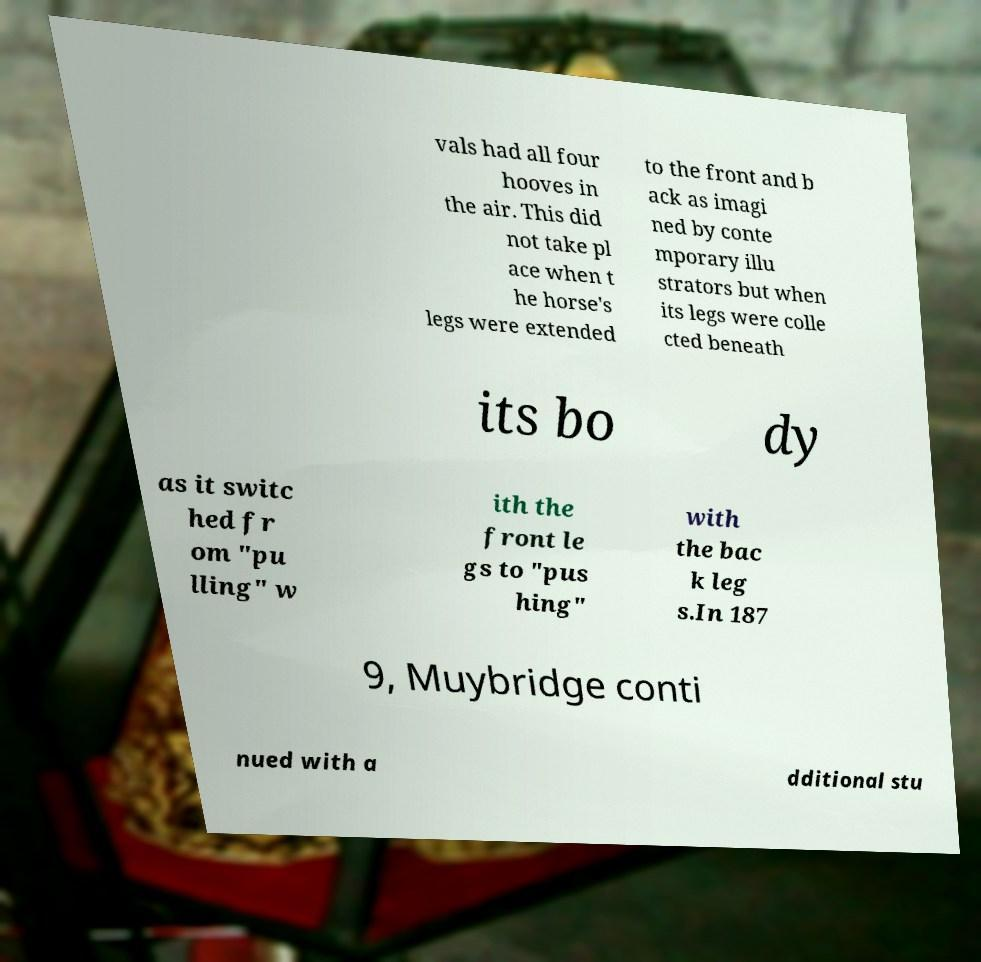For documentation purposes, I need the text within this image transcribed. Could you provide that? vals had all four hooves in the air. This did not take pl ace when t he horse's legs were extended to the front and b ack as imagi ned by conte mporary illu strators but when its legs were colle cted beneath its bo dy as it switc hed fr om "pu lling" w ith the front le gs to "pus hing" with the bac k leg s.In 187 9, Muybridge conti nued with a dditional stu 